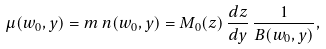<formula> <loc_0><loc_0><loc_500><loc_500>\mu ( w _ { 0 } , y ) = m \, n ( w _ { 0 } , y ) = M _ { 0 } ( z ) \, { \frac { d z } { d y } } \, { \frac { 1 } { B ( w _ { 0 } , y ) } } ,</formula> 